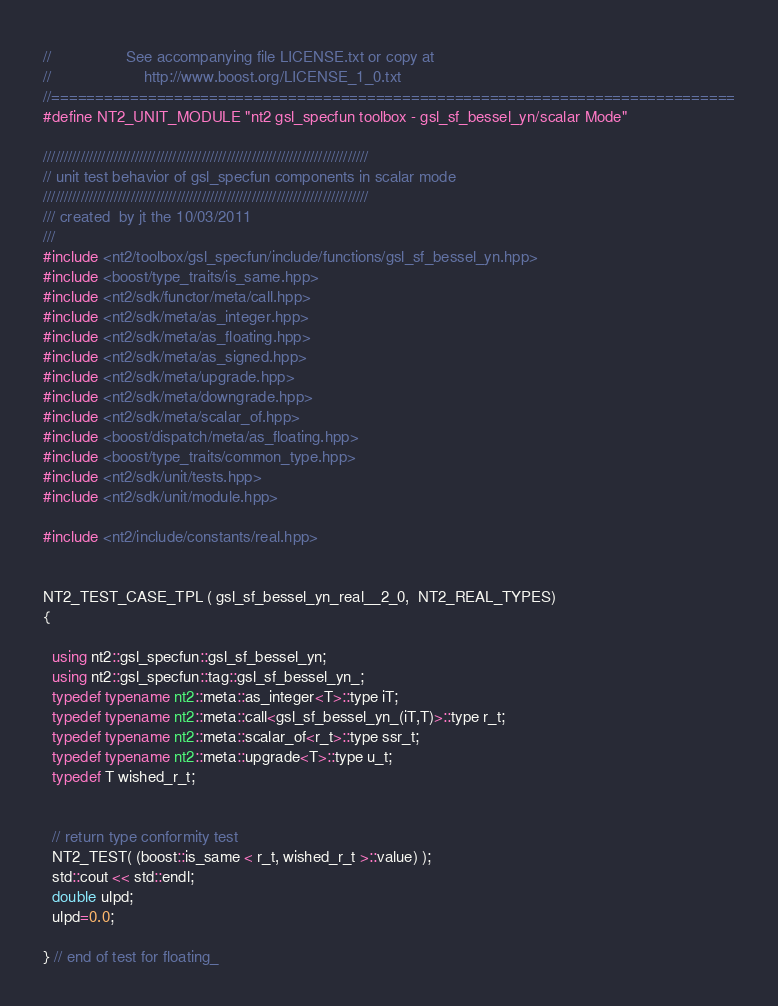Convert code to text. <code><loc_0><loc_0><loc_500><loc_500><_C++_>//                 See accompanying file LICENSE.txt or copy at
//                     http://www.boost.org/LICENSE_1_0.txt
//==============================================================================
#define NT2_UNIT_MODULE "nt2 gsl_specfun toolbox - gsl_sf_bessel_yn/scalar Mode"

//////////////////////////////////////////////////////////////////////////////
// unit test behavior of gsl_specfun components in scalar mode
//////////////////////////////////////////////////////////////////////////////
/// created  by jt the 10/03/2011
///
#include <nt2/toolbox/gsl_specfun/include/functions/gsl_sf_bessel_yn.hpp>
#include <boost/type_traits/is_same.hpp>
#include <nt2/sdk/functor/meta/call.hpp>
#include <nt2/sdk/meta/as_integer.hpp>
#include <nt2/sdk/meta/as_floating.hpp>
#include <nt2/sdk/meta/as_signed.hpp>
#include <nt2/sdk/meta/upgrade.hpp>
#include <nt2/sdk/meta/downgrade.hpp>
#include <nt2/sdk/meta/scalar_of.hpp>
#include <boost/dispatch/meta/as_floating.hpp>
#include <boost/type_traits/common_type.hpp>
#include <nt2/sdk/unit/tests.hpp>
#include <nt2/sdk/unit/module.hpp>

#include <nt2/include/constants/real.hpp>


NT2_TEST_CASE_TPL ( gsl_sf_bessel_yn_real__2_0,  NT2_REAL_TYPES)
{

  using nt2::gsl_specfun::gsl_sf_bessel_yn;
  using nt2::gsl_specfun::tag::gsl_sf_bessel_yn_;
  typedef typename nt2::meta::as_integer<T>::type iT;
  typedef typename nt2::meta::call<gsl_sf_bessel_yn_(iT,T)>::type r_t;
  typedef typename nt2::meta::scalar_of<r_t>::type ssr_t;
  typedef typename nt2::meta::upgrade<T>::type u_t;
  typedef T wished_r_t;


  // return type conformity test
  NT2_TEST( (boost::is_same < r_t, wished_r_t >::value) );
  std::cout << std::endl;
  double ulpd;
  ulpd=0.0;

} // end of test for floating_
</code> 